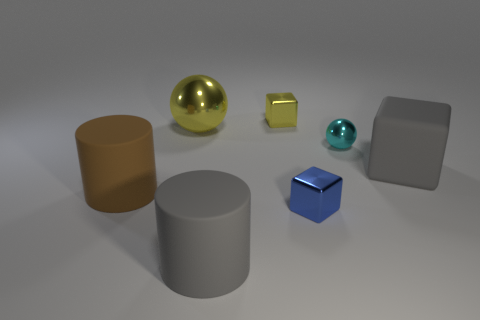Subtract all big rubber cubes. How many cubes are left? 2 Add 2 yellow objects. How many objects exist? 9 Subtract all gray cylinders. How many cylinders are left? 1 Subtract 1 cylinders. How many cylinders are left? 1 Add 6 big brown rubber cylinders. How many big brown rubber cylinders exist? 7 Subtract 1 yellow blocks. How many objects are left? 6 Subtract all cylinders. How many objects are left? 5 Subtract all cyan spheres. Subtract all brown blocks. How many spheres are left? 1 Subtract all red blocks. How many purple cylinders are left? 0 Subtract all cyan metal spheres. Subtract all gray objects. How many objects are left? 4 